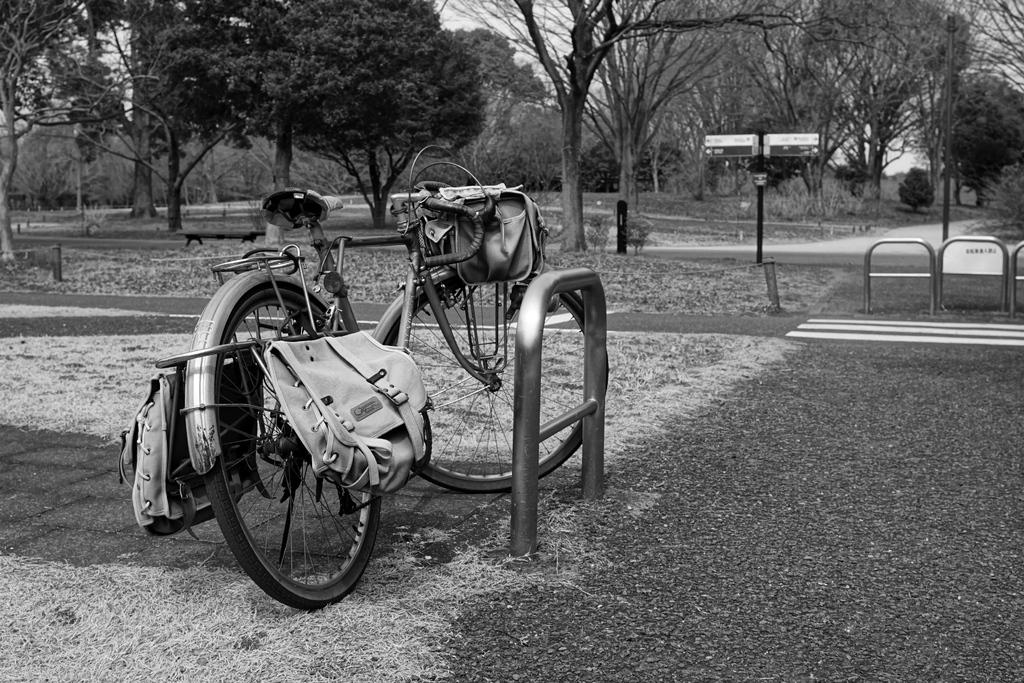What can be seen on the left side of the road in the image? There is a bicycle on the left side of the road in the image. What type of fence is present in the image? There is a metal grill fence in the image. What can be seen in the background of the image? Trees are visible in the background of the image. Where is the marble nest located in the image? There is no marble nest present in the image. What type of lace can be seen on the fence in the image? There is no lace present on the fence in the image; it is a metal grill fence. 